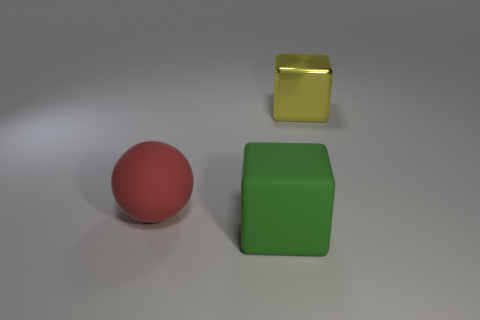Add 1 small cyan spheres. How many objects exist? 4 Subtract all cubes. How many objects are left? 1 Subtract 1 cubes. How many cubes are left? 1 Subtract 0 green spheres. How many objects are left? 3 Subtract all blue spheres. Subtract all purple cylinders. How many spheres are left? 1 Subtract all big green rubber objects. Subtract all big spheres. How many objects are left? 1 Add 2 green blocks. How many green blocks are left? 3 Add 1 small gray rubber cubes. How many small gray rubber cubes exist? 1 